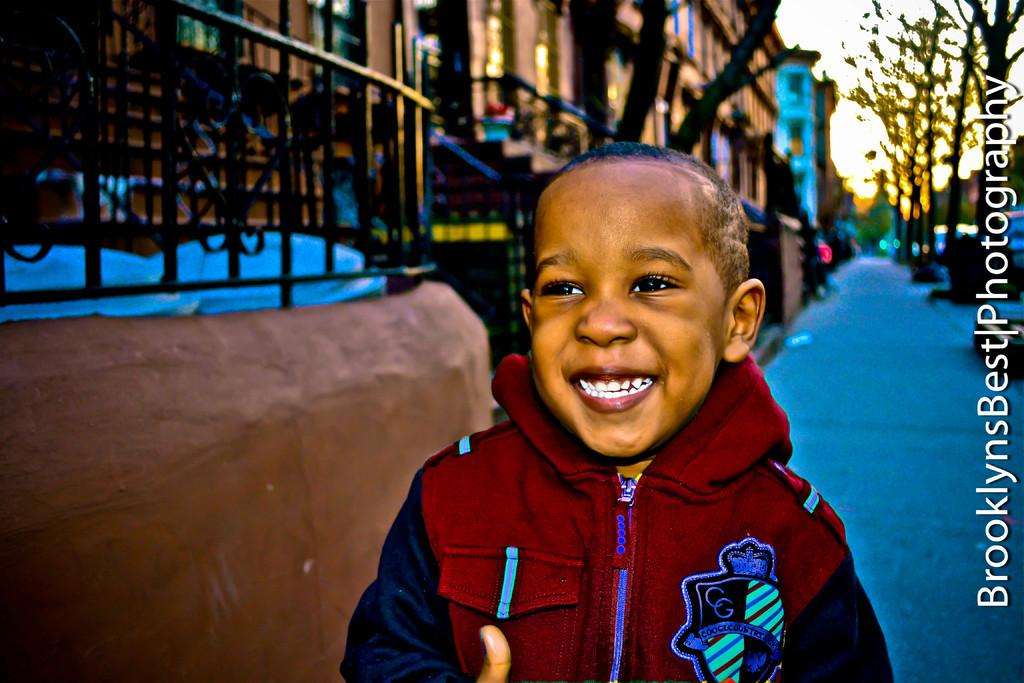What is the main subject of the image? There is a child in the image. What is the child wearing? The child is wearing a red and blue dress. What can be seen in the background of the image? There are buildings, grills, and trees in the background of the image. What book is the child holding in the image? There is no book visible in the image; the child is not holding any object. 